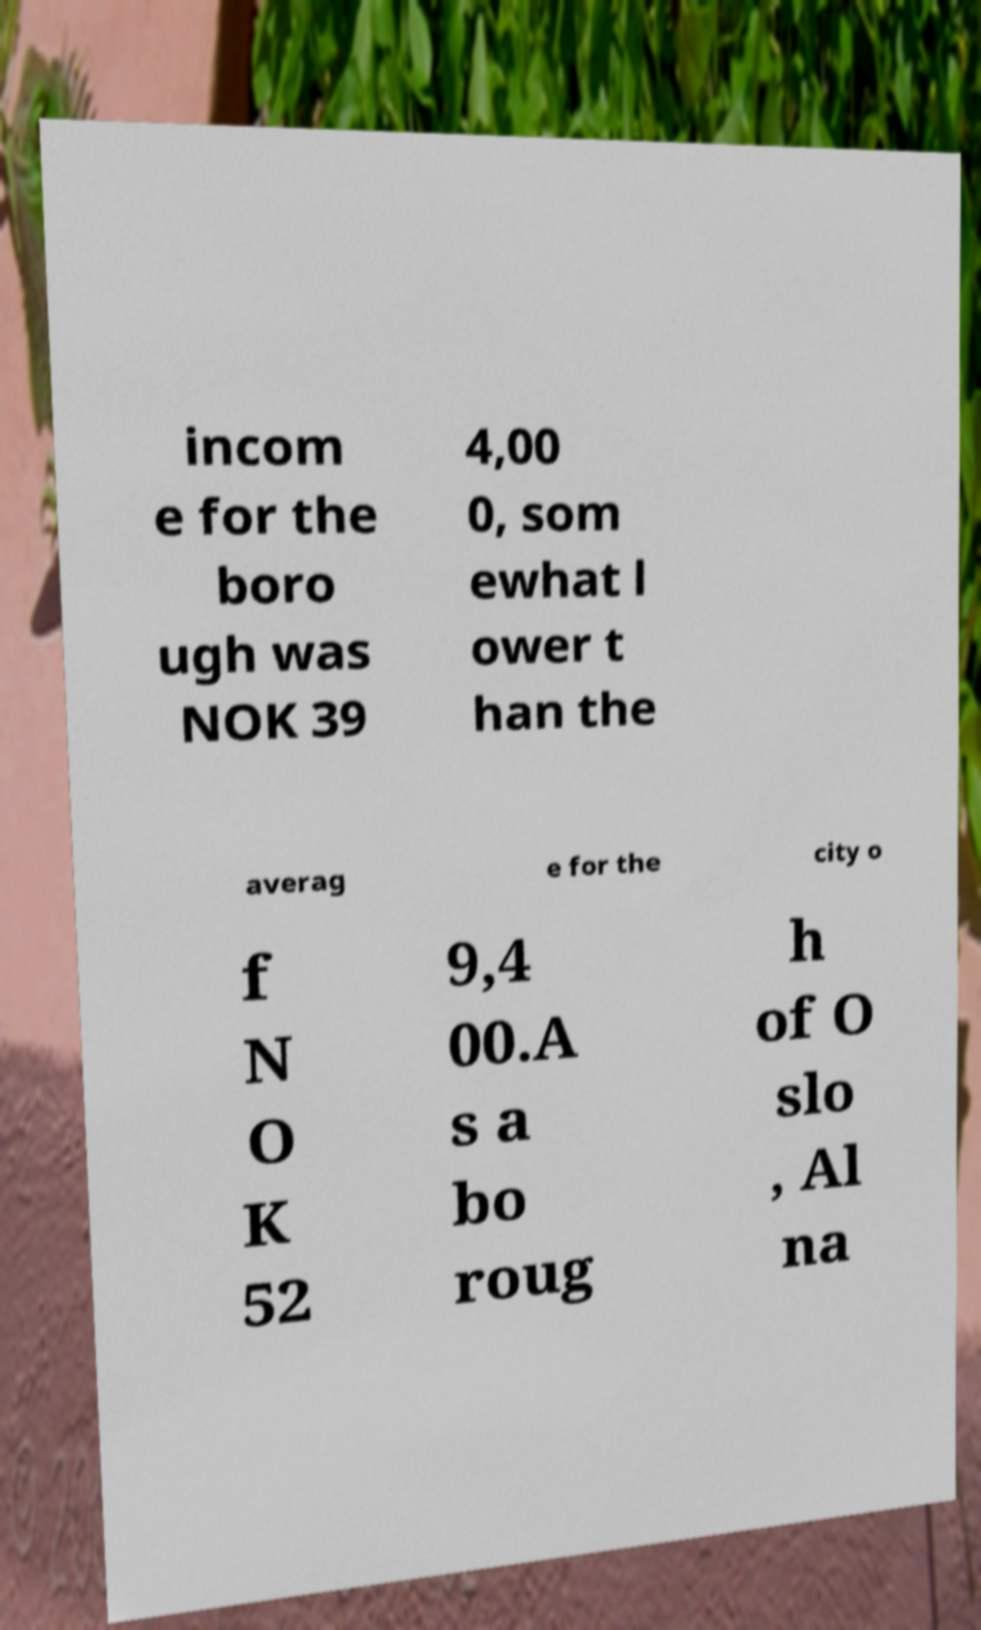Could you assist in decoding the text presented in this image and type it out clearly? incom e for the boro ugh was NOK 39 4,00 0, som ewhat l ower t han the averag e for the city o f N O K 52 9,4 00.A s a bo roug h of O slo , Al na 